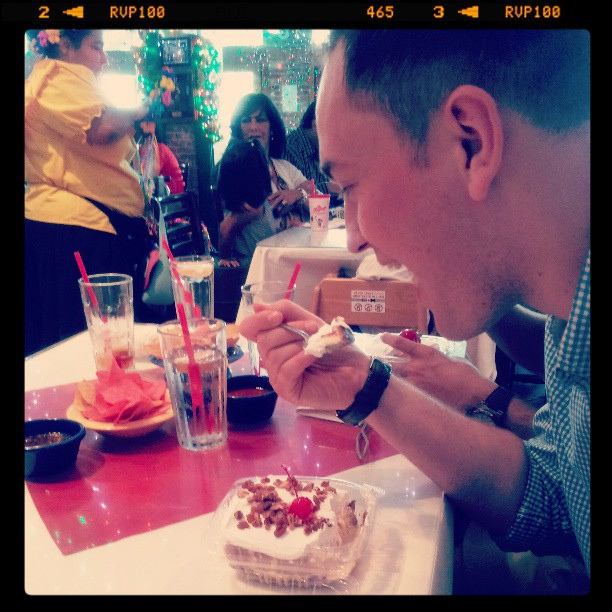Read and extract the text from this image. 2 RVP 100 465 RVP 100 3 